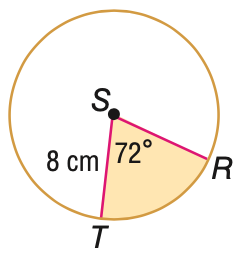Question: Find the area of the shaded sector. Round to the nearest tenth, if necessary.
Choices:
A. 40.2
B. 80.4
C. 160.8
D. 201.1
Answer with the letter. Answer: A 